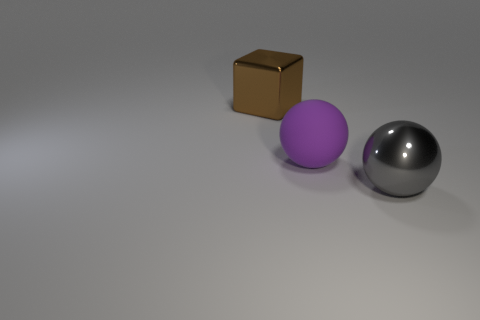What shape is the thing to the left of the rubber sphere that is to the left of the sphere in front of the big matte object?
Ensure brevity in your answer.  Cube. What is the large thing that is both on the left side of the gray ball and right of the big brown metallic thing made of?
Make the answer very short. Rubber. The ball left of the shiny thing that is in front of the sphere behind the metal sphere is what color?
Keep it short and to the point. Purple. How many purple things are matte things or big metal balls?
Provide a short and direct response. 1. How many other objects are the same size as the gray sphere?
Offer a very short reply. 2. What number of big brown cubes are there?
Make the answer very short. 1. Is there any other thing that has the same shape as the gray thing?
Offer a terse response. Yes. Are the big thing to the right of the big purple thing and the large thing left of the big matte sphere made of the same material?
Give a very brief answer. Yes. What is the material of the block?
Your answer should be very brief. Metal. What number of other brown cubes are the same material as the big block?
Offer a very short reply. 0. 